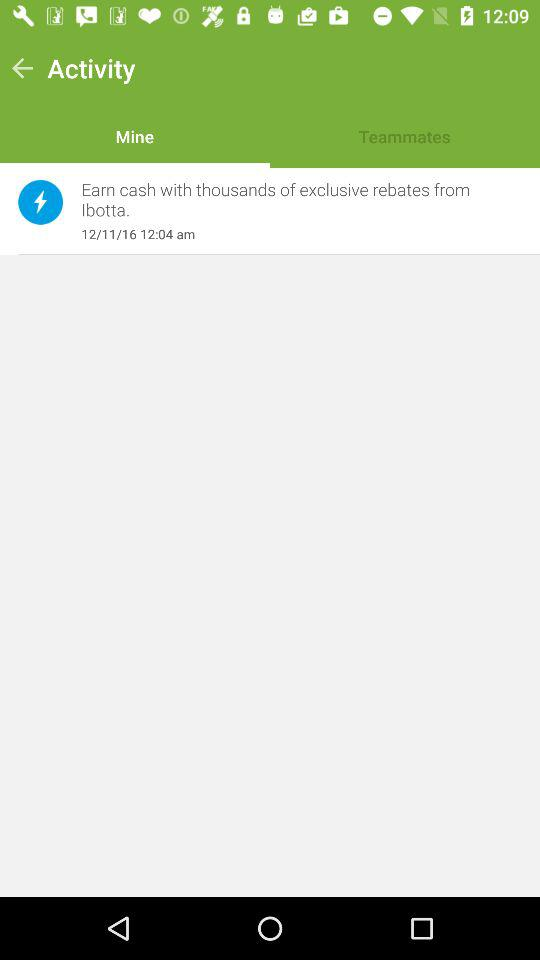What is the selected tab? The selected tab is Mine. 